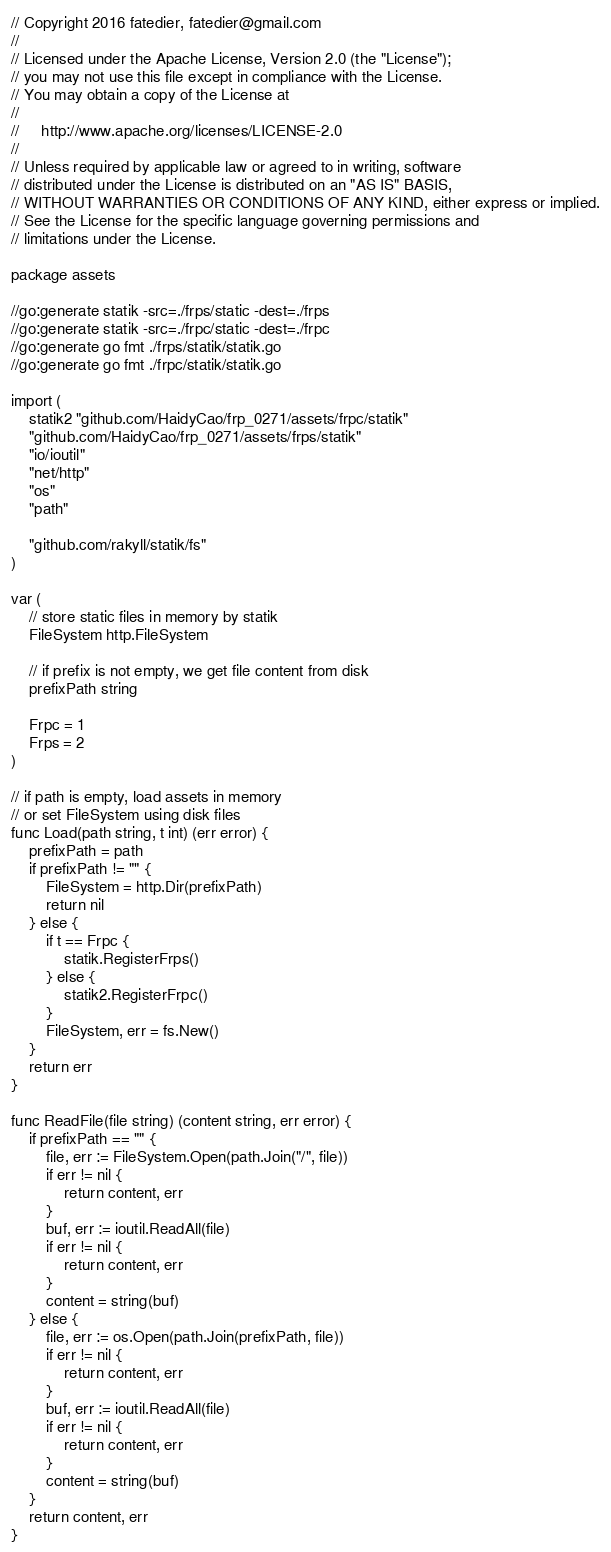Convert code to text. <code><loc_0><loc_0><loc_500><loc_500><_Go_>// Copyright 2016 fatedier, fatedier@gmail.com
//
// Licensed under the Apache License, Version 2.0 (the "License");
// you may not use this file except in compliance with the License.
// You may obtain a copy of the License at
//
//     http://www.apache.org/licenses/LICENSE-2.0
//
// Unless required by applicable law or agreed to in writing, software
// distributed under the License is distributed on an "AS IS" BASIS,
// WITHOUT WARRANTIES OR CONDITIONS OF ANY KIND, either express or implied.
// See the License for the specific language governing permissions and
// limitations under the License.

package assets

//go:generate statik -src=./frps/static -dest=./frps
//go:generate statik -src=./frpc/static -dest=./frpc
//go:generate go fmt ./frps/statik/statik.go
//go:generate go fmt ./frpc/statik/statik.go

import (
	statik2 "github.com/HaidyCao/frp_0271/assets/frpc/statik"
	"github.com/HaidyCao/frp_0271/assets/frps/statik"
	"io/ioutil"
	"net/http"
	"os"
	"path"

	"github.com/rakyll/statik/fs"
)

var (
	// store static files in memory by statik
	FileSystem http.FileSystem

	// if prefix is not empty, we get file content from disk
	prefixPath string

	Frpc = 1
	Frps = 2
)

// if path is empty, load assets in memory
// or set FileSystem using disk files
func Load(path string, t int) (err error) {
	prefixPath = path
	if prefixPath != "" {
		FileSystem = http.Dir(prefixPath)
		return nil
	} else {
		if t == Frpc {
			statik.RegisterFrps()
		} else {
			statik2.RegisterFrpc()
		}
		FileSystem, err = fs.New()
	}
	return err
}

func ReadFile(file string) (content string, err error) {
	if prefixPath == "" {
		file, err := FileSystem.Open(path.Join("/", file))
		if err != nil {
			return content, err
		}
		buf, err := ioutil.ReadAll(file)
		if err != nil {
			return content, err
		}
		content = string(buf)
	} else {
		file, err := os.Open(path.Join(prefixPath, file))
		if err != nil {
			return content, err
		}
		buf, err := ioutil.ReadAll(file)
		if err != nil {
			return content, err
		}
		content = string(buf)
	}
	return content, err
}
</code> 